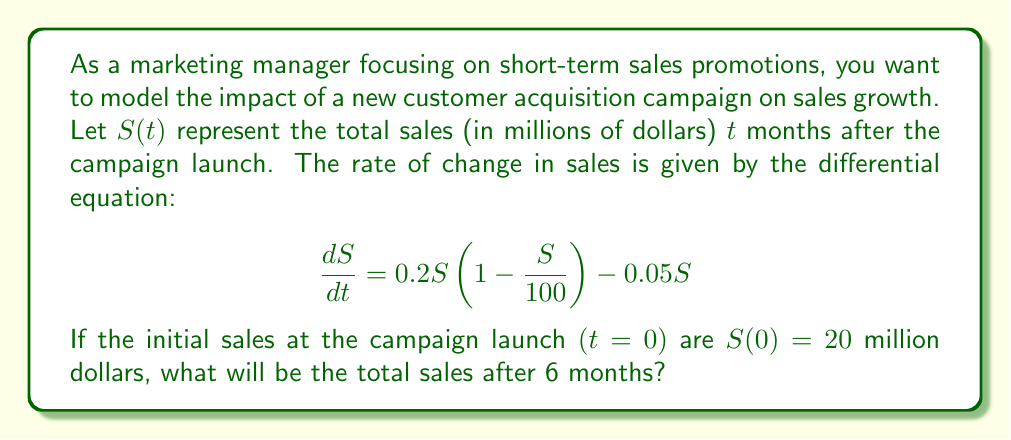Teach me how to tackle this problem. To solve this problem, we need to use the given differential equation and initial condition to find $S(t)$ at $t=6$. Let's break it down step-by-step:

1) The given differential equation is a logistic growth model with a decay term:

   $$ \frac{dS}{dt} = 0.2S(1 - \frac{S}{100}) - 0.05S $$

2) Rearranging the equation:

   $$ \frac{dS}{dt} = 0.2S - 0.002S^2 - 0.05S = 0.15S - 0.002S^2 $$

3) This is a separable differential equation. We can solve it using the method of separation of variables:

   $$ \int \frac{dS}{0.15S - 0.002S^2} = \int dt $$

4) The left-hand side can be integrated using partial fractions:

   $$ \int \frac{dS}{S(0.15 - 0.002S)} = \int \frac{1}{75} (\frac{1}{S} + \frac{0.002}{0.15 - 0.002S}) dS = t + C $$

5) After integration and simplification:

   $$ \frac{1}{75} [\ln|S| - \ln|75 - S|] = t + C $$

6) Using the initial condition $S(0) = 20$, we can find the value of $C$:

   $$ \frac{1}{75} [\ln(20) - \ln(55)] = C $$

7) Substituting this back into the general solution:

   $$ \frac{1}{75} [\ln|S| - \ln|75 - S|] = t + \frac{1}{75} [\ln(20) - \ln(55)] $$

8) Simplifying and solving for $S$:

   $$ S = \frac{75}{1 + (\frac{55}{20})e^{-0.15t}} $$

9) Now, we can find $S(6)$ by plugging in $t=6$:

   $$ S(6) = \frac{75}{1 + (\frac{55}{20})e^{-0.15(6)}} \approx 46.76 $$

Therefore, after 6 months, the total sales will be approximately 46.76 million dollars.
Answer: $46.76 million 